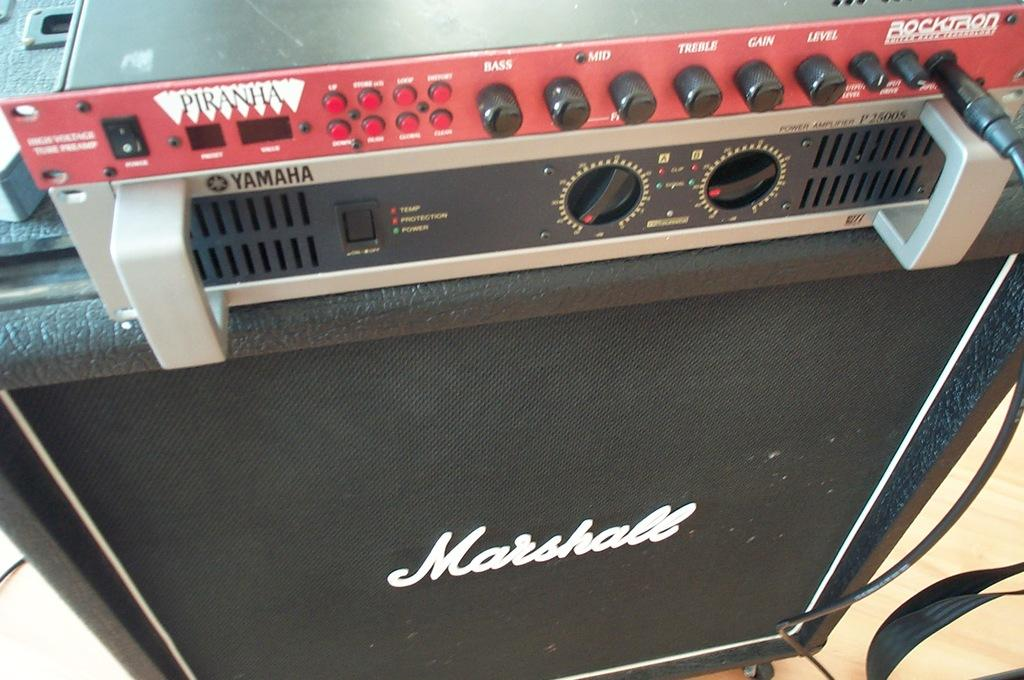Provide a one-sentence caption for the provided image. A sub that says Marshall on the speaker. 